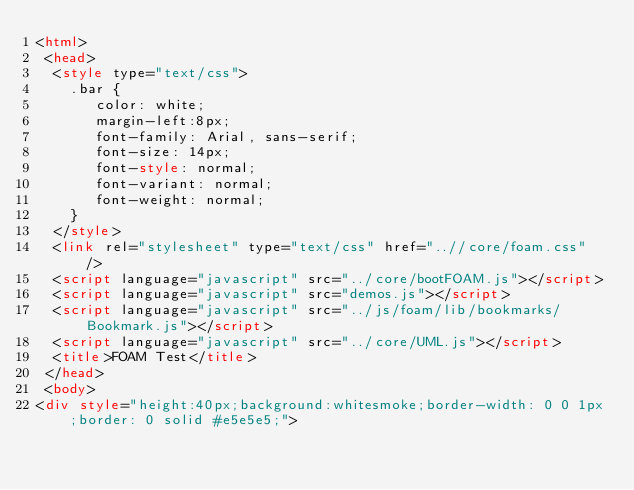Convert code to text. <code><loc_0><loc_0><loc_500><loc_500><_HTML_><html>
 <head>
  <style type="text/css">
    .bar {
       color: white;
       margin-left:8px;
       font-family: Arial, sans-serif;
       font-size: 14px;
       font-style: normal;
       font-variant: normal;
       font-weight: normal;
    }
  </style>
  <link rel="stylesheet" type="text/css" href="..//core/foam.css" />
  <script language="javascript" src="../core/bootFOAM.js"></script>
  <script language="javascript" src="demos.js"></script>
  <script language="javascript" src="../js/foam/lib/bookmarks/Bookmark.js"></script>
  <script language="javascript" src="../core/UML.js"></script>
  <title>FOAM Test</title>
 </head>
 <body>
<div style="height:40px;background:whitesmoke;border-width: 0 0 1px;border: 0 solid #e5e5e5;"></code> 